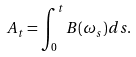<formula> <loc_0><loc_0><loc_500><loc_500>\ A _ { t } = \int _ { 0 } ^ { t } B ( \omega _ { s } ) d s .</formula> 